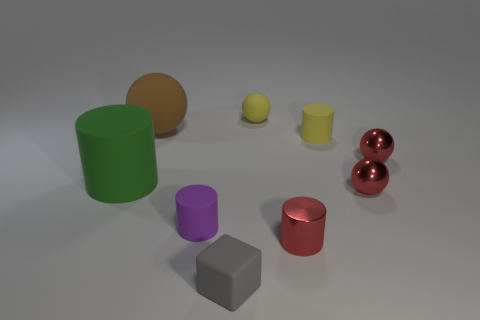There is a matte object that is both on the right side of the small block and in front of the big brown sphere; what is its color?
Keep it short and to the point. Yellow. How many other objects are there of the same shape as the tiny purple object?
Give a very brief answer. 3. There is a rubber sphere to the right of the tiny gray object; is it the same color as the large sphere behind the tiny rubber cube?
Offer a very short reply. No. There is a rubber cylinder that is on the right side of the matte cube; is it the same size as the ball to the left of the yellow sphere?
Keep it short and to the point. No. Are there any other things that have the same material as the tiny purple cylinder?
Offer a very short reply. Yes. The small red thing that is left of the tiny red metal sphere that is in front of the red object that is behind the large matte cylinder is made of what material?
Provide a succinct answer. Metal. Do the large brown matte object and the small gray matte thing have the same shape?
Your response must be concise. No. There is a yellow object that is the same shape as the large green matte object; what material is it?
Offer a very short reply. Rubber. How many objects have the same color as the block?
Offer a very short reply. 0. The yellow cylinder that is made of the same material as the tiny block is what size?
Offer a terse response. Small. 